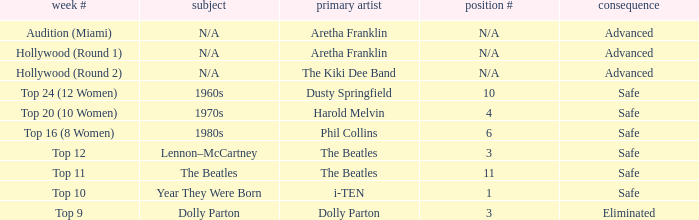What is the original artist of top 9 as the week number? Dolly Parton. 